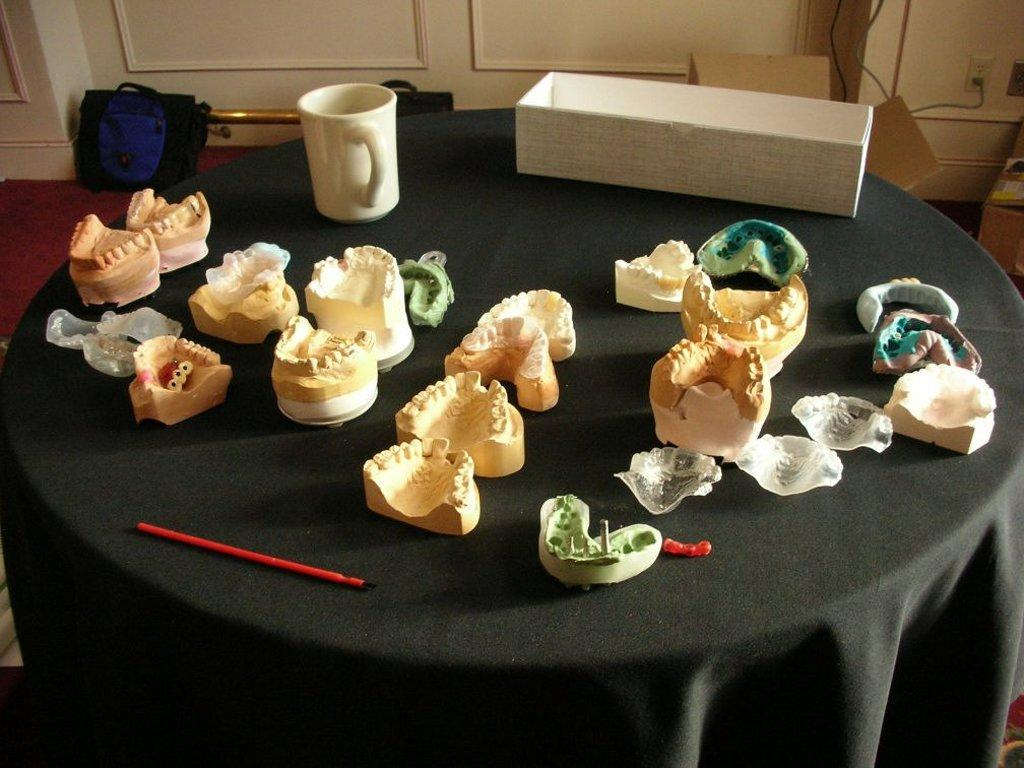What color is the table in the image? The table in the image is black. What can be seen on top of the table? There is a mug and a white box on the table. Are there any other items on the table? Yes, there are unspecified things on the table. What is located in front of the wall? There are bags and cardboard boxes in front of the wall. What can be found on the wall? There are sockets on the wall. What is the floor covering in the image? The floor has a carpet. What type of songs can be heard coming from the boats in the image? There are no boats present in the image, so it is not possible to determine what songs might be heard. What is the wire used for in the image? There is no wire present in the image. 